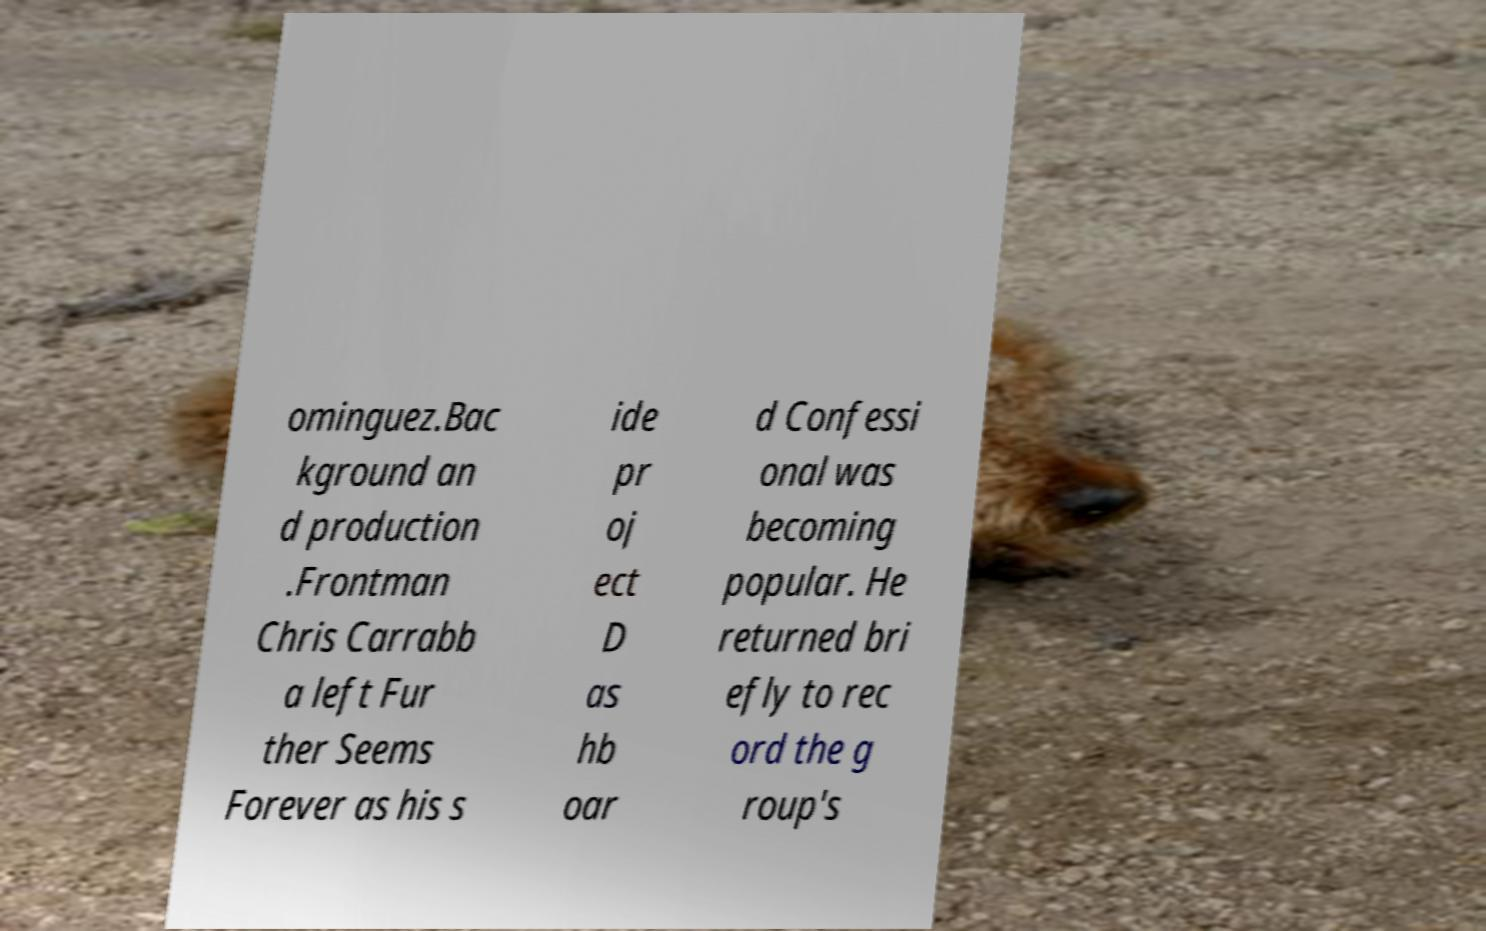There's text embedded in this image that I need extracted. Can you transcribe it verbatim? ominguez.Bac kground an d production .Frontman Chris Carrabb a left Fur ther Seems Forever as his s ide pr oj ect D as hb oar d Confessi onal was becoming popular. He returned bri efly to rec ord the g roup's 